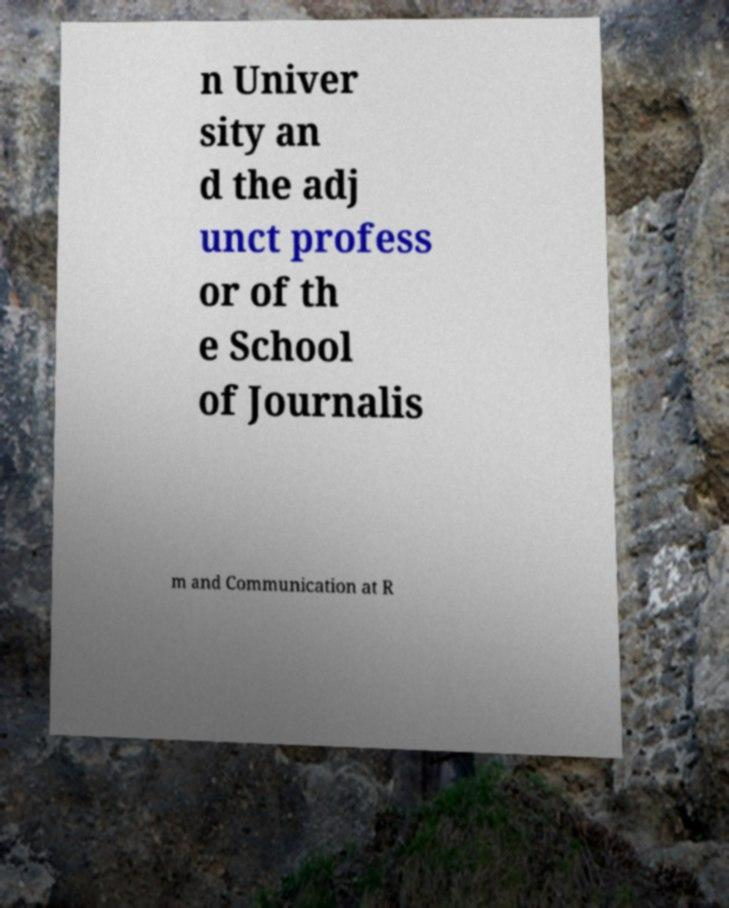Could you assist in decoding the text presented in this image and type it out clearly? n Univer sity an d the adj unct profess or of th e School of Journalis m and Communication at R 